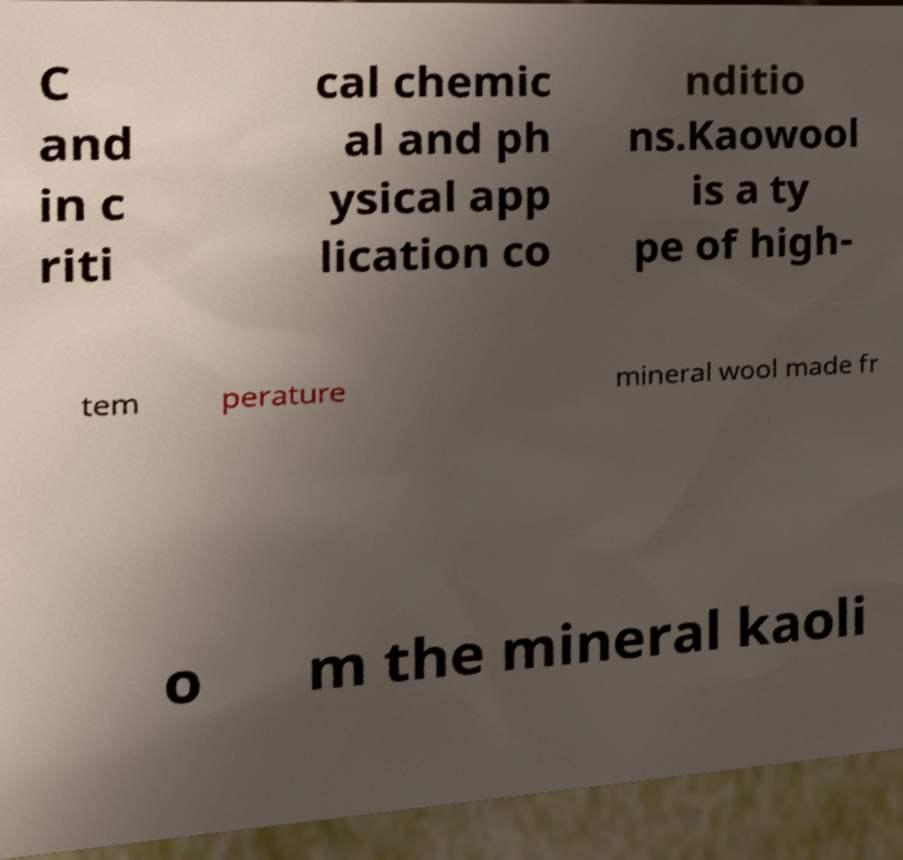Can you accurately transcribe the text from the provided image for me? C and in c riti cal chemic al and ph ysical app lication co nditio ns.Kaowool is a ty pe of high- tem perature mineral wool made fr o m the mineral kaoli 